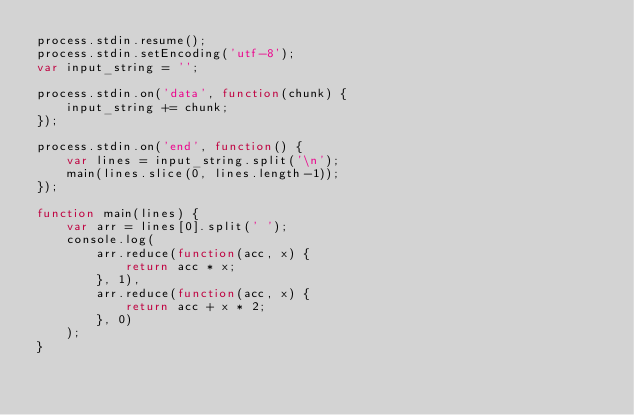Convert code to text. <code><loc_0><loc_0><loc_500><loc_500><_JavaScript_>process.stdin.resume();
process.stdin.setEncoding('utf-8');
var input_string = '';

process.stdin.on('data', function(chunk) {
    input_string += chunk;
});

process.stdin.on('end', function() {
    var lines = input_string.split('\n');
    main(lines.slice(0, lines.length-1));
});

function main(lines) {
    var arr = lines[0].split(' ');
    console.log(
        arr.reduce(function(acc, x) {
            return acc * x;
        }, 1),
        arr.reduce(function(acc, x) {
            return acc + x * 2;
        }, 0)
    );
}</code> 